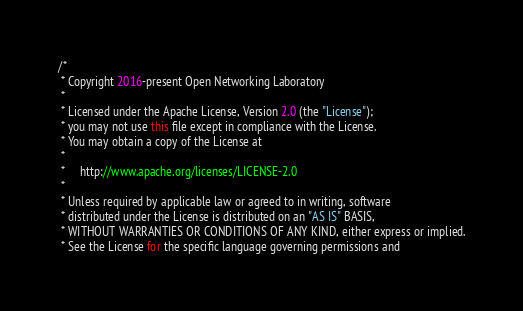<code> <loc_0><loc_0><loc_500><loc_500><_Java_>/*
 * Copyright 2016-present Open Networking Laboratory
 *
 * Licensed under the Apache License, Version 2.0 (the "License");
 * you may not use this file except in compliance with the License.
 * You may obtain a copy of the License at
 *
 *     http://www.apache.org/licenses/LICENSE-2.0
 *
 * Unless required by applicable law or agreed to in writing, software
 * distributed under the License is distributed on an "AS IS" BASIS,
 * WITHOUT WARRANTIES OR CONDITIONS OF ANY KIND, either express or implied.
 * See the License for the specific language governing permissions and</code> 